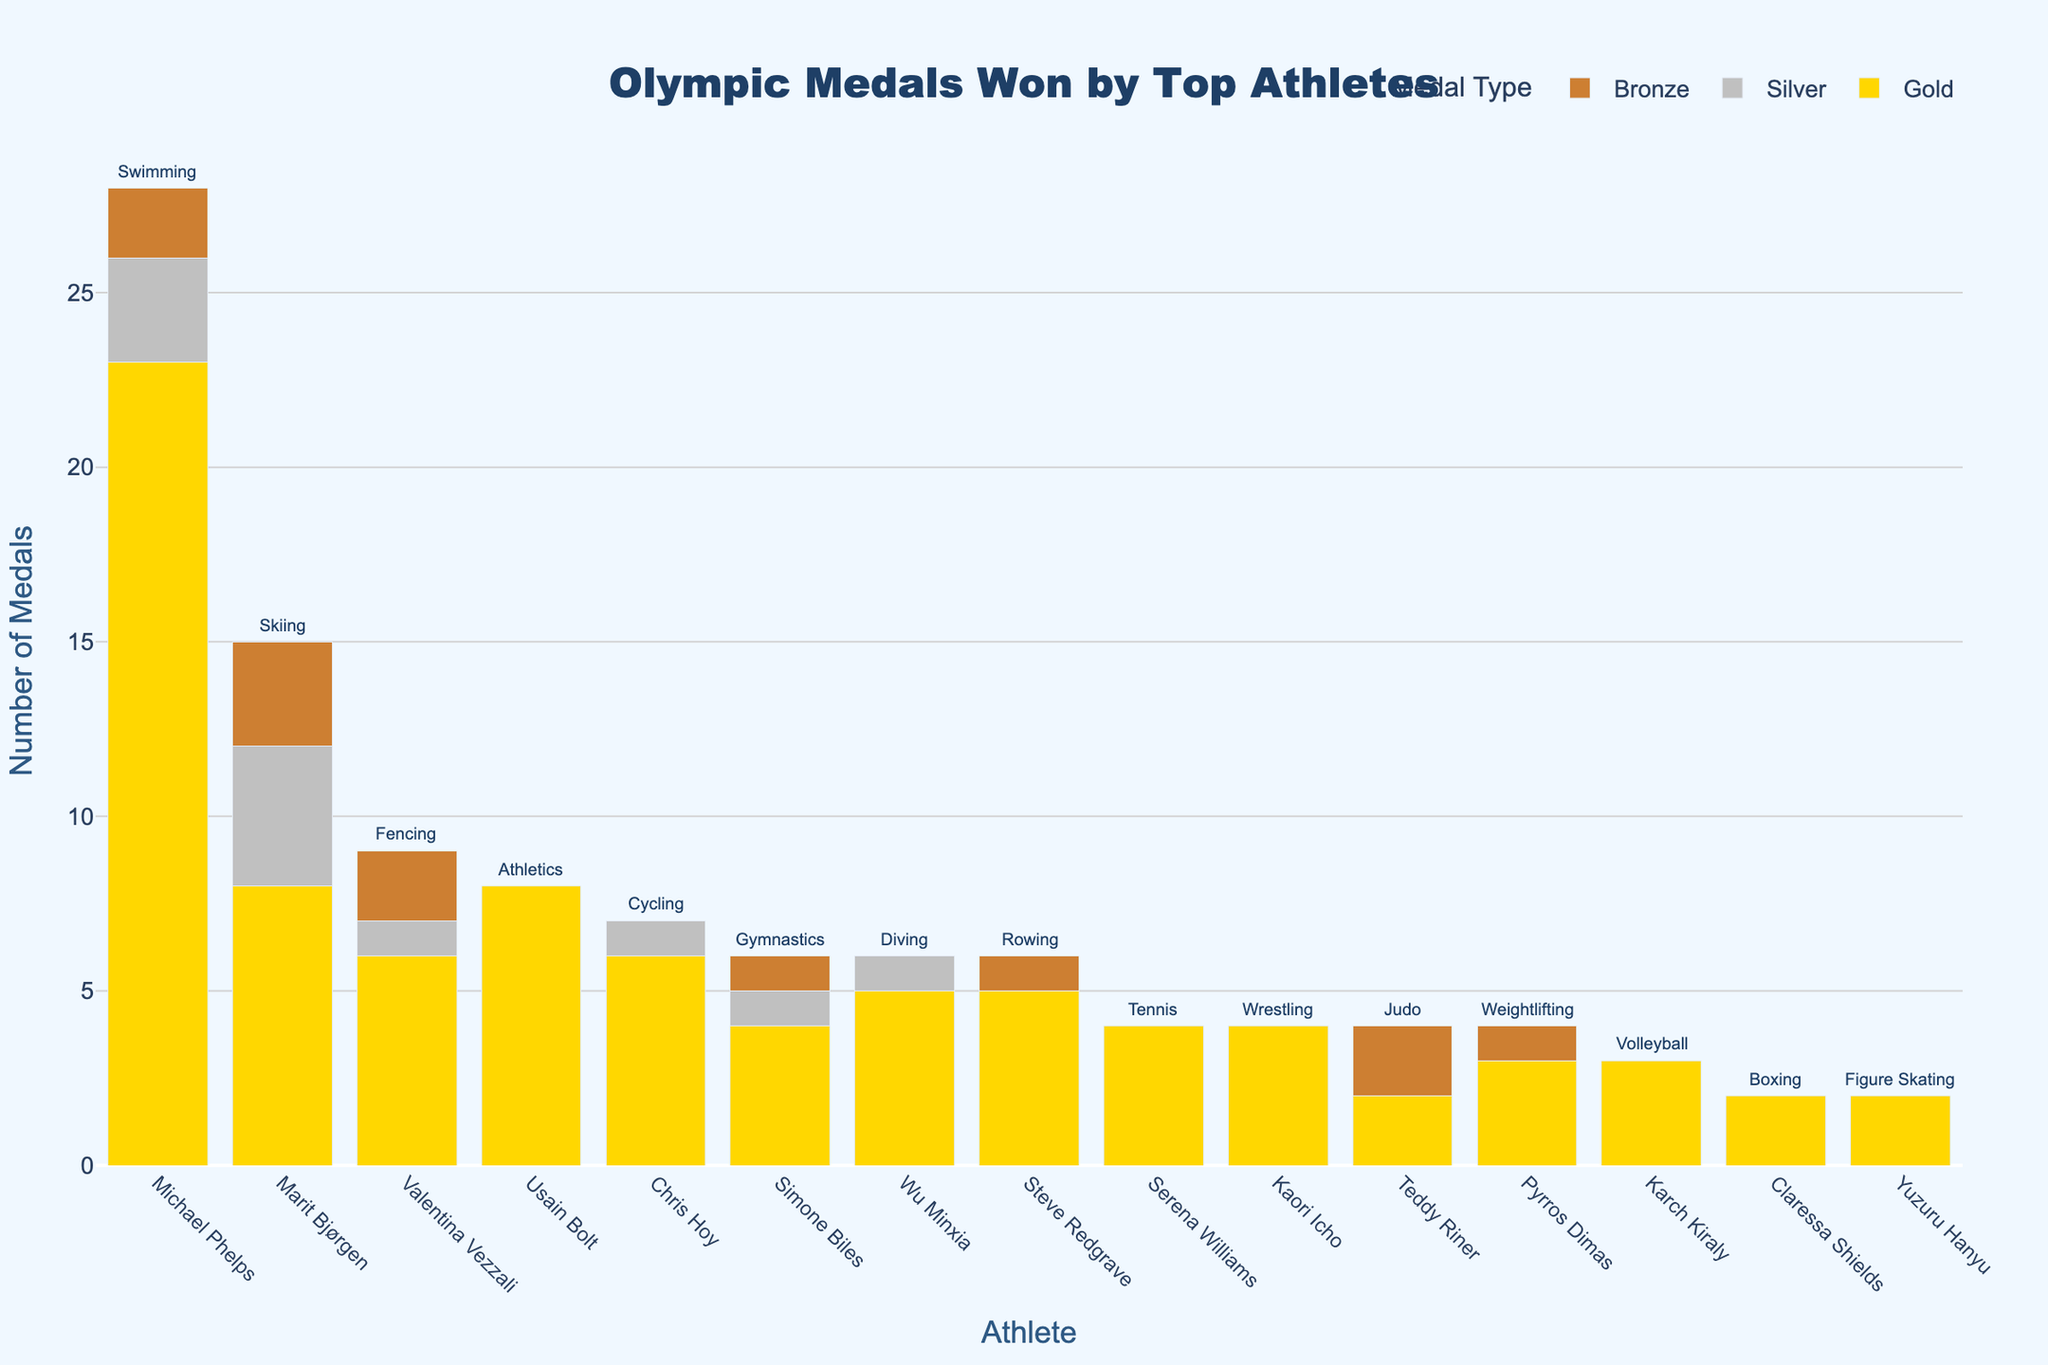Who won the most total medals? The athlete with the highest bar in the 'Total' column of the bar chart indicates the most medals won. This is Michael Phelps, whose bar is significantly taller than the others at 28 medals.
Answer: Michael Phelps Who won the most gold medals? To determine this, we need to look at the bars colored in gold and find the tallest one. Michael Phelps has the tallest gold bar with 23 gold medals.
Answer: Michael Phelps Which athlete in skiing has won the most medals? Locate the athlete associated with "Skiing," which is Marit Bjørgen. Count the total medals represented by her bars. Marit Bjørgen has a total of 15 medals.
Answer: Marit Bjørgen How many total medals were won by the two athletes in the gymnastics and swimming categories combined? First, identify the athletes: Simone Biles (Gymnastics) and Michael Phelps (Swimming). Simone Biles has 6 and Michael Phelps has 28. Sum these values together (6 + 28).
Answer: 34 Which athlete has more medals, Usain Bolt or Serena Williams? Compare the total height of their bars. Usain Bolt's total bar (8 medals) is taller than Serena Williams' (4 medals).
Answer: Usain Bolt Who has more silver medals, Steve Redgrave or Wu Minxia? Check the height of the silver bars for both athletes. Wu Minxia has 1 silver medal, while Steve Redgrave has none (0).
Answer: Wu Minxia Which sport corresponds to athlete Valentina Vezzali, and how many total medals has she won? Find Valentina Vezzali's name on the x-axis and check the annotation above her total medals bar; it mentions "Fencing." The total medals bar shows 9 medals.
Answer: Fencing, 9 What is the difference in the number of gold medals between Chris Hoy and Kaori Icho? Locate both athletes' gold medal bars: Chris Hoy (6 golds) and Kaori Icho (4 golds). The difference is 6 - 4.
Answer: 2 Identify the athlete with the smallest number of medals and name their sport. The athlete with the shortest total bar and corresponding sport text above is Yuzuru Hanyu (Figure Skating) with 2 medals.
Answer: Yuzuru Hanyu, Figure Skating Which athlete has a higher total medal count, Simone Biles or Steve Redgrave? Compare the height of total bars: Simone Biles has 6 medals while Steve Redgrave has 6 as well.
Answer: Equal 